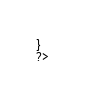<code> <loc_0><loc_0><loc_500><loc_500><_PHP_>}
?></code> 